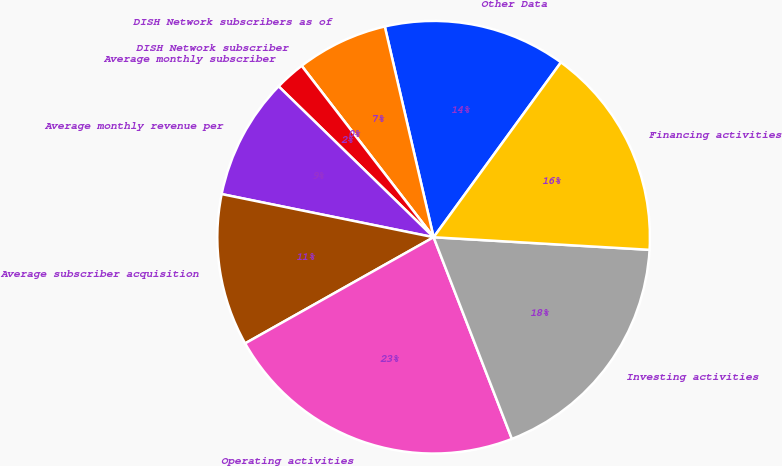<chart> <loc_0><loc_0><loc_500><loc_500><pie_chart><fcel>Other Data<fcel>DISH Network subscribers as of<fcel>DISH Network subscriber<fcel>Average monthly subscriber<fcel>Average monthly revenue per<fcel>Average subscriber acquisition<fcel>Operating activities<fcel>Investing activities<fcel>Financing activities<nl><fcel>13.64%<fcel>6.82%<fcel>0.0%<fcel>2.27%<fcel>9.09%<fcel>11.36%<fcel>22.73%<fcel>18.18%<fcel>15.91%<nl></chart> 